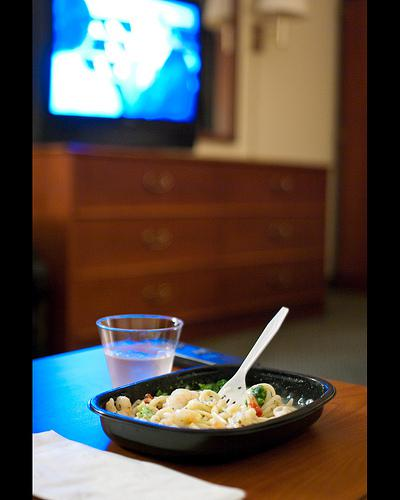Question: what color is the television primarily showing?
Choices:
A. Red.
B. Green.
C. White.
D. Blue.
Answer with the letter. Answer: D Question: what is in the glass?
Choices:
A. Water.
B. Orange Juice.
C. Soda.
D. Milk.
Answer with the letter. Answer: A Question: what appliance is clearly turned on?
Choices:
A. Oven.
B. Television.
C. Microwave.
D. Toaster.
Answer with the letter. Answer: B Question: what kind of carbohydrate is being eaten?
Choices:
A. Pasta.
B. Bread.
C. Crackers.
D. Pancakes.
Answer with the letter. Answer: A Question: how many dinners are there?
Choices:
A. 1.
B. 2.
C. 3.
D. 0.
Answer with the letter. Answer: A 